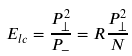Convert formula to latex. <formula><loc_0><loc_0><loc_500><loc_500>E _ { l c } = { \frac { P _ { \perp } ^ { 2 } } { P _ { - } } } = R { \frac { P _ { \perp } ^ { 2 } } { N } }</formula> 